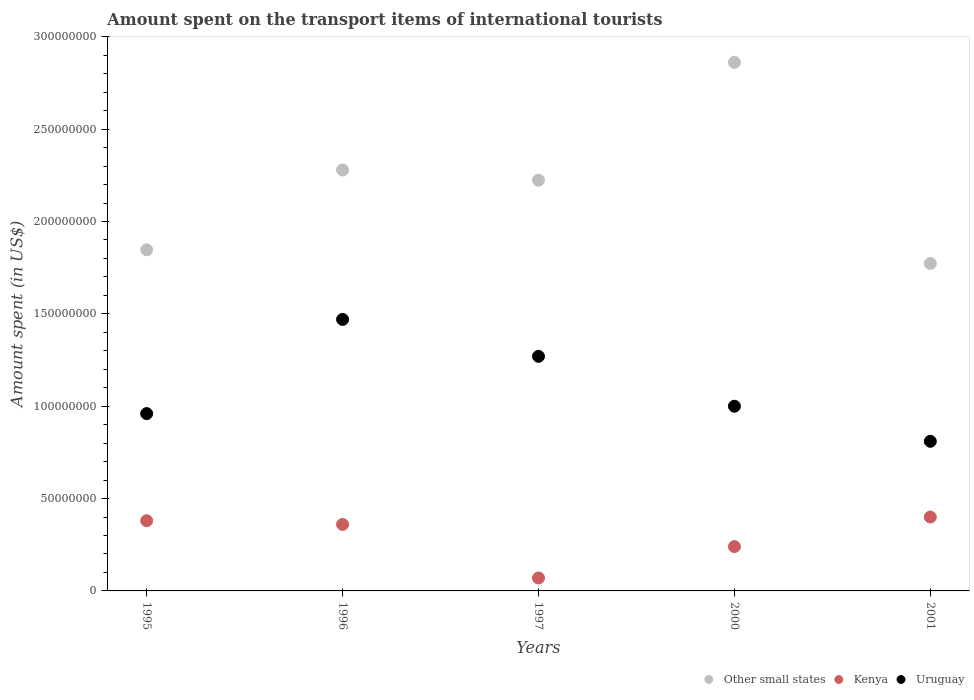What is the amount spent on the transport items of international tourists in Uruguay in 1996?
Give a very brief answer. 1.47e+08. Across all years, what is the maximum amount spent on the transport items of international tourists in Uruguay?
Ensure brevity in your answer.  1.47e+08. Across all years, what is the minimum amount spent on the transport items of international tourists in Kenya?
Offer a very short reply. 7.00e+06. What is the total amount spent on the transport items of international tourists in Other small states in the graph?
Offer a terse response. 1.10e+09. What is the difference between the amount spent on the transport items of international tourists in Other small states in 1995 and that in 2001?
Make the answer very short. 7.38e+06. What is the difference between the amount spent on the transport items of international tourists in Other small states in 1997 and the amount spent on the transport items of international tourists in Uruguay in 2001?
Keep it short and to the point. 1.41e+08. What is the average amount spent on the transport items of international tourists in Uruguay per year?
Give a very brief answer. 1.10e+08. In the year 1995, what is the difference between the amount spent on the transport items of international tourists in Uruguay and amount spent on the transport items of international tourists in Other small states?
Your answer should be very brief. -8.87e+07. In how many years, is the amount spent on the transport items of international tourists in Other small states greater than 40000000 US$?
Provide a short and direct response. 5. What is the ratio of the amount spent on the transport items of international tourists in Other small states in 1996 to that in 2000?
Make the answer very short. 0.8. Is the amount spent on the transport items of international tourists in Uruguay in 1996 less than that in 2000?
Offer a very short reply. No. Is the difference between the amount spent on the transport items of international tourists in Uruguay in 1997 and 2001 greater than the difference between the amount spent on the transport items of international tourists in Other small states in 1997 and 2001?
Give a very brief answer. Yes. What is the difference between the highest and the second highest amount spent on the transport items of international tourists in Kenya?
Your answer should be very brief. 2.00e+06. What is the difference between the highest and the lowest amount spent on the transport items of international tourists in Uruguay?
Your answer should be compact. 6.60e+07. Is the sum of the amount spent on the transport items of international tourists in Kenya in 2000 and 2001 greater than the maximum amount spent on the transport items of international tourists in Uruguay across all years?
Keep it short and to the point. No. Is it the case that in every year, the sum of the amount spent on the transport items of international tourists in Kenya and amount spent on the transport items of international tourists in Other small states  is greater than the amount spent on the transport items of international tourists in Uruguay?
Provide a succinct answer. Yes. Is the amount spent on the transport items of international tourists in Uruguay strictly less than the amount spent on the transport items of international tourists in Other small states over the years?
Give a very brief answer. Yes. How many dotlines are there?
Give a very brief answer. 3. What is the difference between two consecutive major ticks on the Y-axis?
Provide a short and direct response. 5.00e+07. Are the values on the major ticks of Y-axis written in scientific E-notation?
Ensure brevity in your answer.  No. Does the graph contain any zero values?
Offer a terse response. No. How many legend labels are there?
Give a very brief answer. 3. What is the title of the graph?
Make the answer very short. Amount spent on the transport items of international tourists. Does "Argentina" appear as one of the legend labels in the graph?
Your answer should be compact. No. What is the label or title of the X-axis?
Offer a terse response. Years. What is the label or title of the Y-axis?
Your answer should be compact. Amount spent (in US$). What is the Amount spent (in US$) in Other small states in 1995?
Make the answer very short. 1.85e+08. What is the Amount spent (in US$) of Kenya in 1995?
Offer a very short reply. 3.80e+07. What is the Amount spent (in US$) of Uruguay in 1995?
Your answer should be compact. 9.60e+07. What is the Amount spent (in US$) in Other small states in 1996?
Make the answer very short. 2.28e+08. What is the Amount spent (in US$) in Kenya in 1996?
Provide a short and direct response. 3.60e+07. What is the Amount spent (in US$) of Uruguay in 1996?
Provide a succinct answer. 1.47e+08. What is the Amount spent (in US$) of Other small states in 1997?
Your answer should be very brief. 2.22e+08. What is the Amount spent (in US$) of Kenya in 1997?
Offer a terse response. 7.00e+06. What is the Amount spent (in US$) of Uruguay in 1997?
Give a very brief answer. 1.27e+08. What is the Amount spent (in US$) in Other small states in 2000?
Keep it short and to the point. 2.86e+08. What is the Amount spent (in US$) of Kenya in 2000?
Your answer should be very brief. 2.40e+07. What is the Amount spent (in US$) in Uruguay in 2000?
Give a very brief answer. 1.00e+08. What is the Amount spent (in US$) of Other small states in 2001?
Your response must be concise. 1.77e+08. What is the Amount spent (in US$) in Kenya in 2001?
Provide a succinct answer. 4.00e+07. What is the Amount spent (in US$) in Uruguay in 2001?
Offer a terse response. 8.10e+07. Across all years, what is the maximum Amount spent (in US$) in Other small states?
Ensure brevity in your answer.  2.86e+08. Across all years, what is the maximum Amount spent (in US$) of Kenya?
Keep it short and to the point. 4.00e+07. Across all years, what is the maximum Amount spent (in US$) of Uruguay?
Ensure brevity in your answer.  1.47e+08. Across all years, what is the minimum Amount spent (in US$) of Other small states?
Offer a very short reply. 1.77e+08. Across all years, what is the minimum Amount spent (in US$) of Uruguay?
Give a very brief answer. 8.10e+07. What is the total Amount spent (in US$) of Other small states in the graph?
Make the answer very short. 1.10e+09. What is the total Amount spent (in US$) in Kenya in the graph?
Give a very brief answer. 1.45e+08. What is the total Amount spent (in US$) in Uruguay in the graph?
Your answer should be very brief. 5.51e+08. What is the difference between the Amount spent (in US$) of Other small states in 1995 and that in 1996?
Your response must be concise. -4.32e+07. What is the difference between the Amount spent (in US$) in Kenya in 1995 and that in 1996?
Make the answer very short. 2.00e+06. What is the difference between the Amount spent (in US$) in Uruguay in 1995 and that in 1996?
Make the answer very short. -5.10e+07. What is the difference between the Amount spent (in US$) of Other small states in 1995 and that in 1997?
Provide a short and direct response. -3.77e+07. What is the difference between the Amount spent (in US$) of Kenya in 1995 and that in 1997?
Your answer should be compact. 3.10e+07. What is the difference between the Amount spent (in US$) of Uruguay in 1995 and that in 1997?
Your response must be concise. -3.10e+07. What is the difference between the Amount spent (in US$) of Other small states in 1995 and that in 2000?
Your answer should be very brief. -1.02e+08. What is the difference between the Amount spent (in US$) of Kenya in 1995 and that in 2000?
Offer a terse response. 1.40e+07. What is the difference between the Amount spent (in US$) of Uruguay in 1995 and that in 2000?
Ensure brevity in your answer.  -4.00e+06. What is the difference between the Amount spent (in US$) in Other small states in 1995 and that in 2001?
Provide a succinct answer. 7.38e+06. What is the difference between the Amount spent (in US$) of Uruguay in 1995 and that in 2001?
Your answer should be very brief. 1.50e+07. What is the difference between the Amount spent (in US$) of Other small states in 1996 and that in 1997?
Offer a terse response. 5.52e+06. What is the difference between the Amount spent (in US$) of Kenya in 1996 and that in 1997?
Provide a short and direct response. 2.90e+07. What is the difference between the Amount spent (in US$) in Uruguay in 1996 and that in 1997?
Ensure brevity in your answer.  2.00e+07. What is the difference between the Amount spent (in US$) in Other small states in 1996 and that in 2000?
Make the answer very short. -5.83e+07. What is the difference between the Amount spent (in US$) of Kenya in 1996 and that in 2000?
Keep it short and to the point. 1.20e+07. What is the difference between the Amount spent (in US$) in Uruguay in 1996 and that in 2000?
Offer a terse response. 4.70e+07. What is the difference between the Amount spent (in US$) in Other small states in 1996 and that in 2001?
Ensure brevity in your answer.  5.06e+07. What is the difference between the Amount spent (in US$) in Uruguay in 1996 and that in 2001?
Offer a very short reply. 6.60e+07. What is the difference between the Amount spent (in US$) of Other small states in 1997 and that in 2000?
Provide a short and direct response. -6.38e+07. What is the difference between the Amount spent (in US$) of Kenya in 1997 and that in 2000?
Your answer should be compact. -1.70e+07. What is the difference between the Amount spent (in US$) of Uruguay in 1997 and that in 2000?
Keep it short and to the point. 2.70e+07. What is the difference between the Amount spent (in US$) of Other small states in 1997 and that in 2001?
Provide a short and direct response. 4.51e+07. What is the difference between the Amount spent (in US$) in Kenya in 1997 and that in 2001?
Provide a short and direct response. -3.30e+07. What is the difference between the Amount spent (in US$) of Uruguay in 1997 and that in 2001?
Ensure brevity in your answer.  4.60e+07. What is the difference between the Amount spent (in US$) of Other small states in 2000 and that in 2001?
Offer a terse response. 1.09e+08. What is the difference between the Amount spent (in US$) of Kenya in 2000 and that in 2001?
Make the answer very short. -1.60e+07. What is the difference between the Amount spent (in US$) in Uruguay in 2000 and that in 2001?
Offer a very short reply. 1.90e+07. What is the difference between the Amount spent (in US$) in Other small states in 1995 and the Amount spent (in US$) in Kenya in 1996?
Offer a very short reply. 1.49e+08. What is the difference between the Amount spent (in US$) of Other small states in 1995 and the Amount spent (in US$) of Uruguay in 1996?
Keep it short and to the point. 3.77e+07. What is the difference between the Amount spent (in US$) of Kenya in 1995 and the Amount spent (in US$) of Uruguay in 1996?
Make the answer very short. -1.09e+08. What is the difference between the Amount spent (in US$) of Other small states in 1995 and the Amount spent (in US$) of Kenya in 1997?
Provide a short and direct response. 1.78e+08. What is the difference between the Amount spent (in US$) of Other small states in 1995 and the Amount spent (in US$) of Uruguay in 1997?
Your answer should be compact. 5.77e+07. What is the difference between the Amount spent (in US$) in Kenya in 1995 and the Amount spent (in US$) in Uruguay in 1997?
Make the answer very short. -8.90e+07. What is the difference between the Amount spent (in US$) of Other small states in 1995 and the Amount spent (in US$) of Kenya in 2000?
Make the answer very short. 1.61e+08. What is the difference between the Amount spent (in US$) in Other small states in 1995 and the Amount spent (in US$) in Uruguay in 2000?
Your answer should be compact. 8.47e+07. What is the difference between the Amount spent (in US$) in Kenya in 1995 and the Amount spent (in US$) in Uruguay in 2000?
Offer a terse response. -6.20e+07. What is the difference between the Amount spent (in US$) of Other small states in 1995 and the Amount spent (in US$) of Kenya in 2001?
Offer a very short reply. 1.45e+08. What is the difference between the Amount spent (in US$) of Other small states in 1995 and the Amount spent (in US$) of Uruguay in 2001?
Offer a terse response. 1.04e+08. What is the difference between the Amount spent (in US$) in Kenya in 1995 and the Amount spent (in US$) in Uruguay in 2001?
Ensure brevity in your answer.  -4.30e+07. What is the difference between the Amount spent (in US$) in Other small states in 1996 and the Amount spent (in US$) in Kenya in 1997?
Your response must be concise. 2.21e+08. What is the difference between the Amount spent (in US$) in Other small states in 1996 and the Amount spent (in US$) in Uruguay in 1997?
Ensure brevity in your answer.  1.01e+08. What is the difference between the Amount spent (in US$) of Kenya in 1996 and the Amount spent (in US$) of Uruguay in 1997?
Make the answer very short. -9.10e+07. What is the difference between the Amount spent (in US$) in Other small states in 1996 and the Amount spent (in US$) in Kenya in 2000?
Offer a very short reply. 2.04e+08. What is the difference between the Amount spent (in US$) in Other small states in 1996 and the Amount spent (in US$) in Uruguay in 2000?
Your answer should be compact. 1.28e+08. What is the difference between the Amount spent (in US$) of Kenya in 1996 and the Amount spent (in US$) of Uruguay in 2000?
Provide a succinct answer. -6.40e+07. What is the difference between the Amount spent (in US$) in Other small states in 1996 and the Amount spent (in US$) in Kenya in 2001?
Offer a terse response. 1.88e+08. What is the difference between the Amount spent (in US$) in Other small states in 1996 and the Amount spent (in US$) in Uruguay in 2001?
Offer a very short reply. 1.47e+08. What is the difference between the Amount spent (in US$) of Kenya in 1996 and the Amount spent (in US$) of Uruguay in 2001?
Your answer should be very brief. -4.50e+07. What is the difference between the Amount spent (in US$) of Other small states in 1997 and the Amount spent (in US$) of Kenya in 2000?
Your answer should be compact. 1.98e+08. What is the difference between the Amount spent (in US$) in Other small states in 1997 and the Amount spent (in US$) in Uruguay in 2000?
Your response must be concise. 1.22e+08. What is the difference between the Amount spent (in US$) in Kenya in 1997 and the Amount spent (in US$) in Uruguay in 2000?
Give a very brief answer. -9.30e+07. What is the difference between the Amount spent (in US$) in Other small states in 1997 and the Amount spent (in US$) in Kenya in 2001?
Offer a very short reply. 1.82e+08. What is the difference between the Amount spent (in US$) in Other small states in 1997 and the Amount spent (in US$) in Uruguay in 2001?
Your answer should be very brief. 1.41e+08. What is the difference between the Amount spent (in US$) in Kenya in 1997 and the Amount spent (in US$) in Uruguay in 2001?
Give a very brief answer. -7.40e+07. What is the difference between the Amount spent (in US$) of Other small states in 2000 and the Amount spent (in US$) of Kenya in 2001?
Keep it short and to the point. 2.46e+08. What is the difference between the Amount spent (in US$) in Other small states in 2000 and the Amount spent (in US$) in Uruguay in 2001?
Your answer should be compact. 2.05e+08. What is the difference between the Amount spent (in US$) of Kenya in 2000 and the Amount spent (in US$) of Uruguay in 2001?
Keep it short and to the point. -5.70e+07. What is the average Amount spent (in US$) in Other small states per year?
Your answer should be very brief. 2.20e+08. What is the average Amount spent (in US$) in Kenya per year?
Provide a succinct answer. 2.90e+07. What is the average Amount spent (in US$) of Uruguay per year?
Offer a terse response. 1.10e+08. In the year 1995, what is the difference between the Amount spent (in US$) of Other small states and Amount spent (in US$) of Kenya?
Provide a succinct answer. 1.47e+08. In the year 1995, what is the difference between the Amount spent (in US$) of Other small states and Amount spent (in US$) of Uruguay?
Your answer should be very brief. 8.87e+07. In the year 1995, what is the difference between the Amount spent (in US$) in Kenya and Amount spent (in US$) in Uruguay?
Your response must be concise. -5.80e+07. In the year 1996, what is the difference between the Amount spent (in US$) in Other small states and Amount spent (in US$) in Kenya?
Your answer should be very brief. 1.92e+08. In the year 1996, what is the difference between the Amount spent (in US$) in Other small states and Amount spent (in US$) in Uruguay?
Make the answer very short. 8.09e+07. In the year 1996, what is the difference between the Amount spent (in US$) in Kenya and Amount spent (in US$) in Uruguay?
Offer a very short reply. -1.11e+08. In the year 1997, what is the difference between the Amount spent (in US$) in Other small states and Amount spent (in US$) in Kenya?
Provide a succinct answer. 2.15e+08. In the year 1997, what is the difference between the Amount spent (in US$) in Other small states and Amount spent (in US$) in Uruguay?
Your response must be concise. 9.54e+07. In the year 1997, what is the difference between the Amount spent (in US$) in Kenya and Amount spent (in US$) in Uruguay?
Keep it short and to the point. -1.20e+08. In the year 2000, what is the difference between the Amount spent (in US$) of Other small states and Amount spent (in US$) of Kenya?
Provide a succinct answer. 2.62e+08. In the year 2000, what is the difference between the Amount spent (in US$) of Other small states and Amount spent (in US$) of Uruguay?
Give a very brief answer. 1.86e+08. In the year 2000, what is the difference between the Amount spent (in US$) of Kenya and Amount spent (in US$) of Uruguay?
Make the answer very short. -7.60e+07. In the year 2001, what is the difference between the Amount spent (in US$) of Other small states and Amount spent (in US$) of Kenya?
Give a very brief answer. 1.37e+08. In the year 2001, what is the difference between the Amount spent (in US$) in Other small states and Amount spent (in US$) in Uruguay?
Give a very brief answer. 9.63e+07. In the year 2001, what is the difference between the Amount spent (in US$) in Kenya and Amount spent (in US$) in Uruguay?
Provide a short and direct response. -4.10e+07. What is the ratio of the Amount spent (in US$) in Other small states in 1995 to that in 1996?
Your answer should be very brief. 0.81. What is the ratio of the Amount spent (in US$) in Kenya in 1995 to that in 1996?
Your answer should be very brief. 1.06. What is the ratio of the Amount spent (in US$) of Uruguay in 1995 to that in 1996?
Your answer should be very brief. 0.65. What is the ratio of the Amount spent (in US$) of Other small states in 1995 to that in 1997?
Give a very brief answer. 0.83. What is the ratio of the Amount spent (in US$) in Kenya in 1995 to that in 1997?
Your answer should be very brief. 5.43. What is the ratio of the Amount spent (in US$) in Uruguay in 1995 to that in 1997?
Ensure brevity in your answer.  0.76. What is the ratio of the Amount spent (in US$) in Other small states in 1995 to that in 2000?
Ensure brevity in your answer.  0.65. What is the ratio of the Amount spent (in US$) in Kenya in 1995 to that in 2000?
Provide a short and direct response. 1.58. What is the ratio of the Amount spent (in US$) in Other small states in 1995 to that in 2001?
Make the answer very short. 1.04. What is the ratio of the Amount spent (in US$) of Kenya in 1995 to that in 2001?
Your response must be concise. 0.95. What is the ratio of the Amount spent (in US$) in Uruguay in 1995 to that in 2001?
Offer a terse response. 1.19. What is the ratio of the Amount spent (in US$) in Other small states in 1996 to that in 1997?
Keep it short and to the point. 1.02. What is the ratio of the Amount spent (in US$) of Kenya in 1996 to that in 1997?
Offer a very short reply. 5.14. What is the ratio of the Amount spent (in US$) in Uruguay in 1996 to that in 1997?
Offer a very short reply. 1.16. What is the ratio of the Amount spent (in US$) of Other small states in 1996 to that in 2000?
Your answer should be very brief. 0.8. What is the ratio of the Amount spent (in US$) in Kenya in 1996 to that in 2000?
Give a very brief answer. 1.5. What is the ratio of the Amount spent (in US$) in Uruguay in 1996 to that in 2000?
Give a very brief answer. 1.47. What is the ratio of the Amount spent (in US$) in Other small states in 1996 to that in 2001?
Provide a short and direct response. 1.29. What is the ratio of the Amount spent (in US$) in Uruguay in 1996 to that in 2001?
Your answer should be very brief. 1.81. What is the ratio of the Amount spent (in US$) in Other small states in 1997 to that in 2000?
Make the answer very short. 0.78. What is the ratio of the Amount spent (in US$) in Kenya in 1997 to that in 2000?
Your response must be concise. 0.29. What is the ratio of the Amount spent (in US$) in Uruguay in 1997 to that in 2000?
Provide a short and direct response. 1.27. What is the ratio of the Amount spent (in US$) in Other small states in 1997 to that in 2001?
Ensure brevity in your answer.  1.25. What is the ratio of the Amount spent (in US$) of Kenya in 1997 to that in 2001?
Make the answer very short. 0.17. What is the ratio of the Amount spent (in US$) in Uruguay in 1997 to that in 2001?
Your answer should be compact. 1.57. What is the ratio of the Amount spent (in US$) in Other small states in 2000 to that in 2001?
Provide a succinct answer. 1.61. What is the ratio of the Amount spent (in US$) of Uruguay in 2000 to that in 2001?
Your answer should be very brief. 1.23. What is the difference between the highest and the second highest Amount spent (in US$) of Other small states?
Your response must be concise. 5.83e+07. What is the difference between the highest and the second highest Amount spent (in US$) in Uruguay?
Offer a terse response. 2.00e+07. What is the difference between the highest and the lowest Amount spent (in US$) of Other small states?
Make the answer very short. 1.09e+08. What is the difference between the highest and the lowest Amount spent (in US$) in Kenya?
Your answer should be very brief. 3.30e+07. What is the difference between the highest and the lowest Amount spent (in US$) in Uruguay?
Your answer should be very brief. 6.60e+07. 